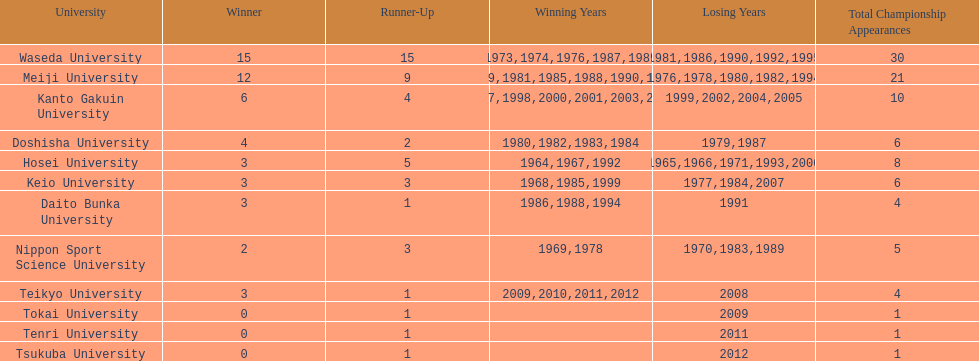What university were there in the all-japan university rugby championship? Waseda University, Meiji University, Kanto Gakuin University, Doshisha University, Hosei University, Keio University, Daito Bunka University, Nippon Sport Science University, Teikyo University, Tokai University, Tenri University, Tsukuba University. Of these who had more than 12 wins? Waseda University. 